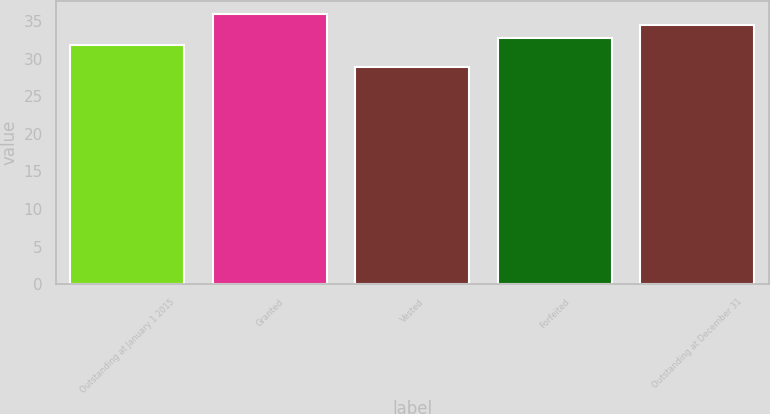Convert chart to OTSL. <chart><loc_0><loc_0><loc_500><loc_500><bar_chart><fcel>Outstanding at January 1 2015<fcel>Granted<fcel>Vested<fcel>Forfeited<fcel>Outstanding at December 31<nl><fcel>31.8<fcel>35.87<fcel>28.85<fcel>32.75<fcel>34.52<nl></chart> 